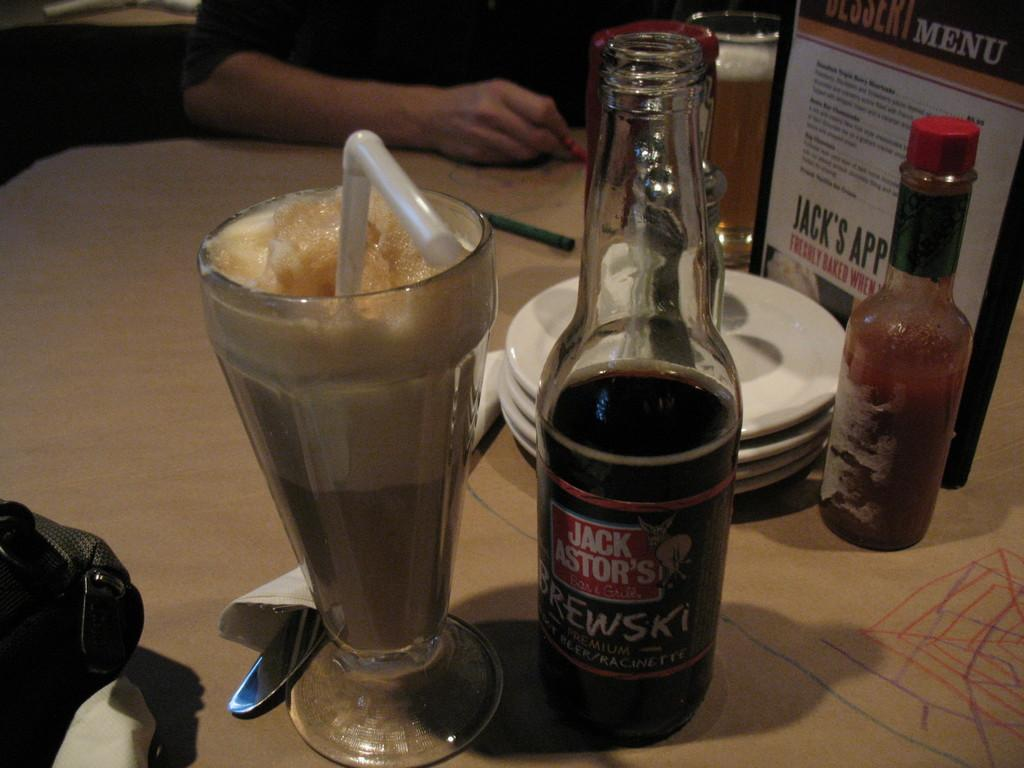<image>
Summarize the visual content of the image. A sign on the restaurant table advertises Jack's app. 